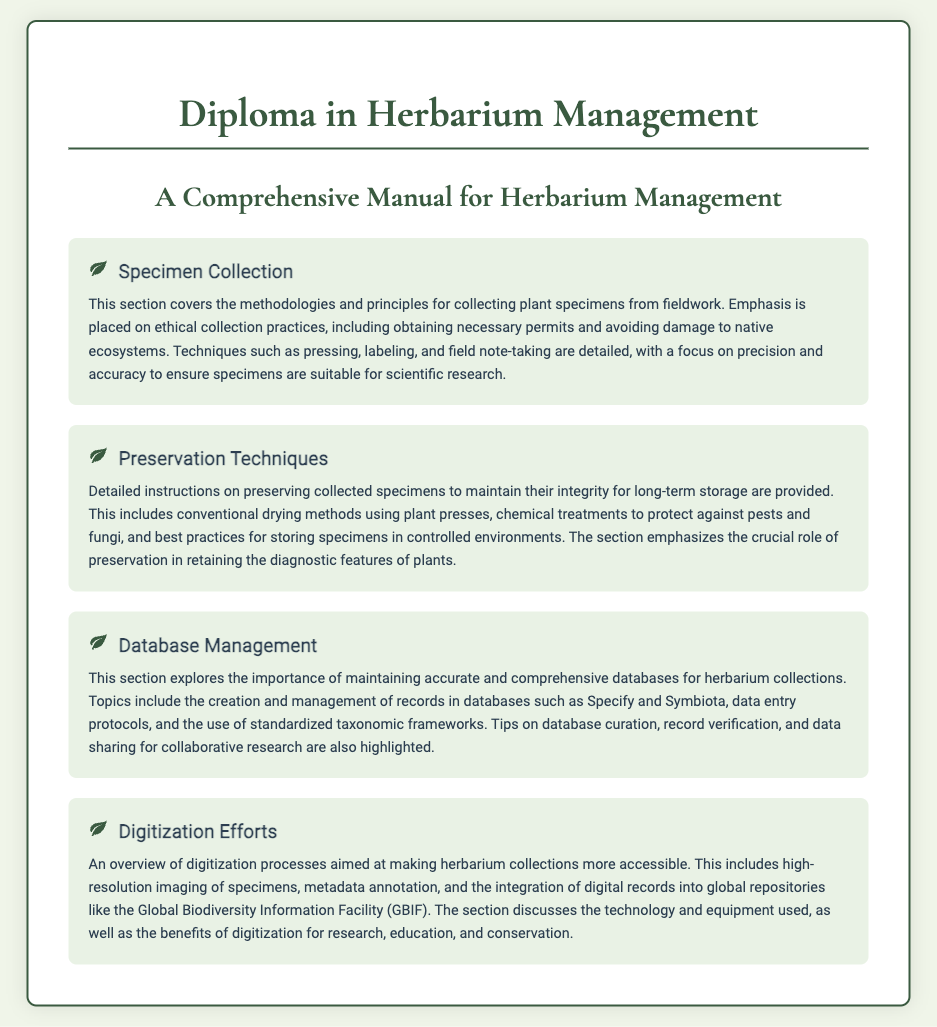what is the title of the diploma? The title of the diploma is prominently displayed in the document's header.
Answer: Diploma in Herbarium Management what is the focus of the specimen collection section? The focus of the specimen collection section is outlined in the content relating to ethical practices and techniques.
Answer: Ethical collection practices what is emphasized in the preservation techniques section? The preservation techniques section emphasizes methods for maintaining specimen integrity.
Answer: Maintaining their integrity which databases are mentioned in the database management section? The document specifically mentions databases relevant to herbarium management.
Answer: Specify and Symbiota what is the purpose of digitization efforts? The purpose of digitization efforts is summarized in the section discussing accessibility and technology used.
Answer: Making herbarium collections more accessible why is ethical collecting emphasized in the document? Ethical collecting is emphasized to highlight the importance of responsible practices in specimen collection methods.
Answer: Responsible practices what type of imaging is discussed in the digitization efforts section? The type of imaging discussed in this section relates to the quality of specimen documentation.
Answer: High-resolution imaging what is a key benefit of digitization mentioned? The document highlights a significant benefit of digitization for broader accessibility in various fields.
Answer: Research, education, and conservation 